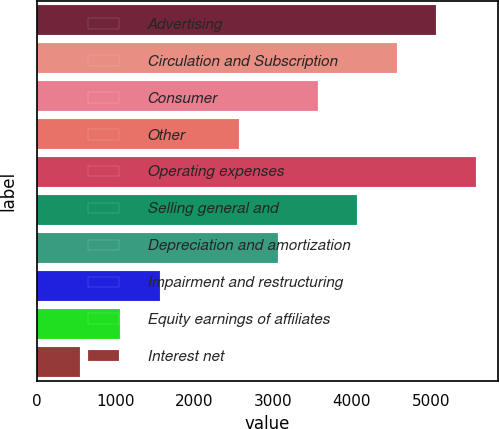Convert chart. <chart><loc_0><loc_0><loc_500><loc_500><bar_chart><fcel>Advertising<fcel>Circulation and Subscription<fcel>Consumer<fcel>Other<fcel>Operating expenses<fcel>Selling general and<fcel>Depreciation and amortization<fcel>Impairment and restructuring<fcel>Equity earnings of affiliates<fcel>Interest net<nl><fcel>5074<fcel>4572.1<fcel>3568.3<fcel>2564.5<fcel>5575.9<fcel>4070.2<fcel>3066.4<fcel>1560.7<fcel>1058.8<fcel>556.9<nl></chart> 